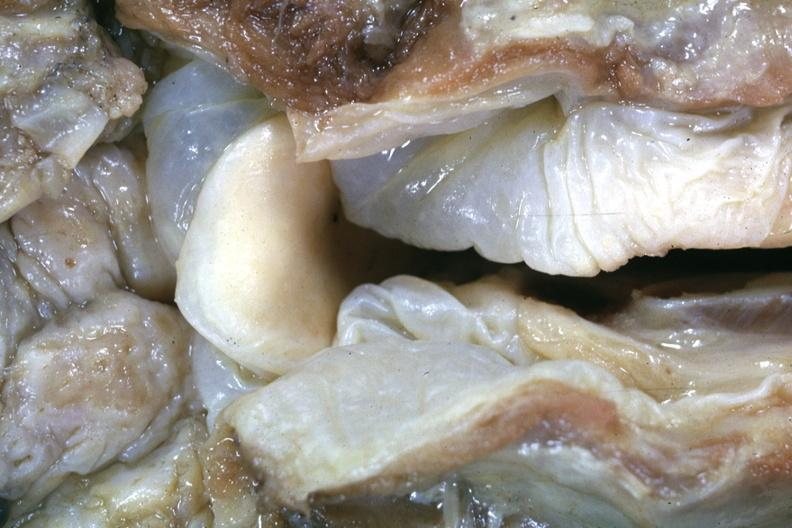what is close-up view of very edematous hypopharyngeal mucosa with opened larynx this is a very good example of a lesion seldom seen at autopsy slide more distant view of this specimen after fixation?
Answer the question using a single word or phrase. Slide 